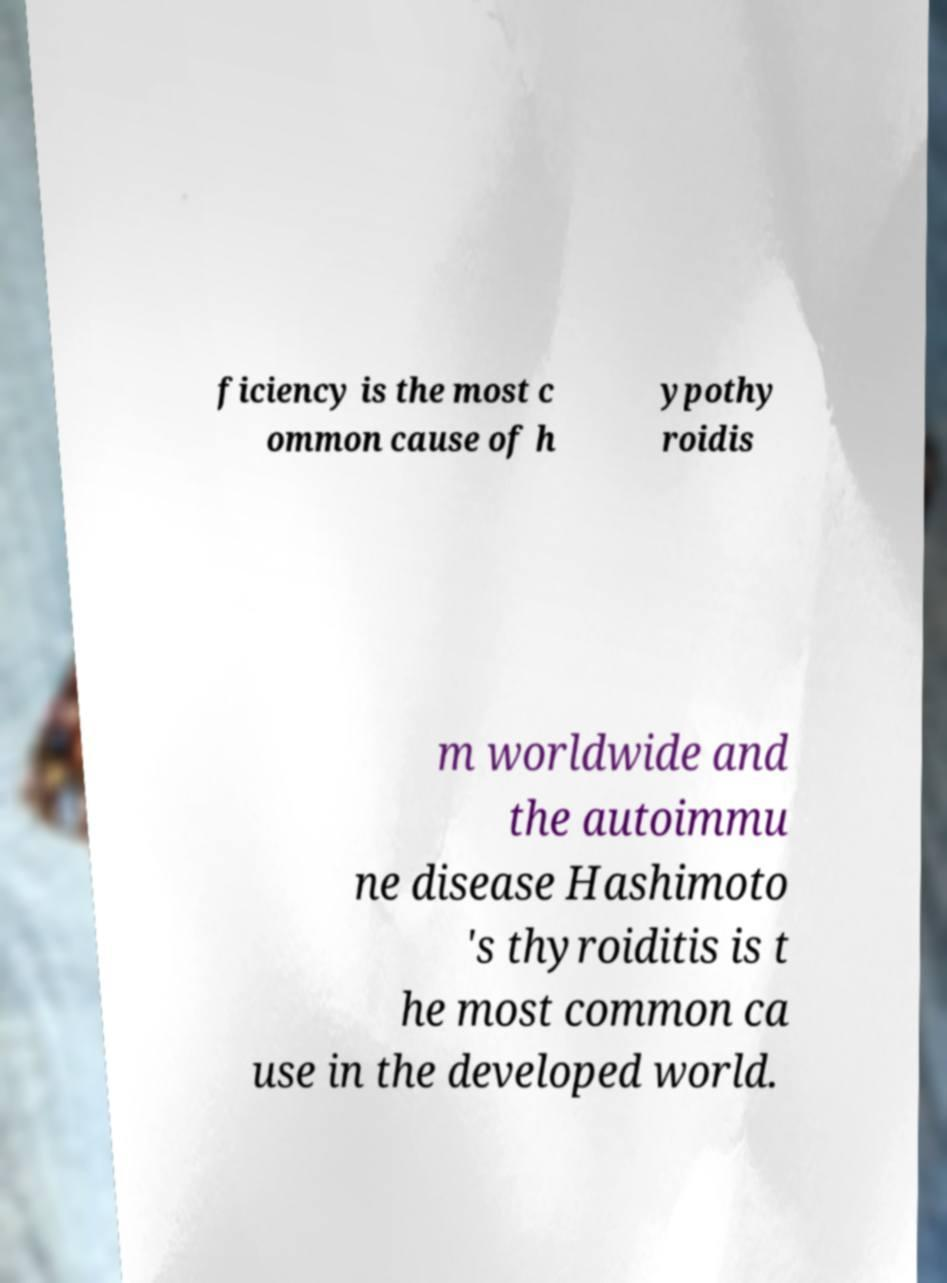Please read and relay the text visible in this image. What does it say? ficiency is the most c ommon cause of h ypothy roidis m worldwide and the autoimmu ne disease Hashimoto 's thyroiditis is t he most common ca use in the developed world. 